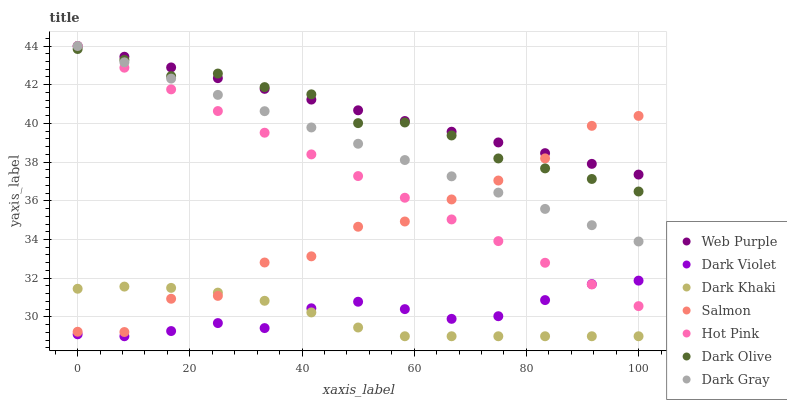Does Dark Khaki have the minimum area under the curve?
Answer yes or no. Yes. Does Web Purple have the maximum area under the curve?
Answer yes or no. Yes. Does Dark Olive have the minimum area under the curve?
Answer yes or no. No. Does Dark Olive have the maximum area under the curve?
Answer yes or no. No. Is Hot Pink the smoothest?
Answer yes or no. Yes. Is Salmon the roughest?
Answer yes or no. Yes. Is Dark Olive the smoothest?
Answer yes or no. No. Is Dark Olive the roughest?
Answer yes or no. No. Does Dark Violet have the lowest value?
Answer yes or no. Yes. Does Dark Olive have the lowest value?
Answer yes or no. No. Does Web Purple have the highest value?
Answer yes or no. Yes. Does Dark Olive have the highest value?
Answer yes or no. No. Is Dark Khaki less than Hot Pink?
Answer yes or no. Yes. Is Dark Gray greater than Dark Khaki?
Answer yes or no. Yes. Does Dark Olive intersect Salmon?
Answer yes or no. Yes. Is Dark Olive less than Salmon?
Answer yes or no. No. Is Dark Olive greater than Salmon?
Answer yes or no. No. Does Dark Khaki intersect Hot Pink?
Answer yes or no. No. 